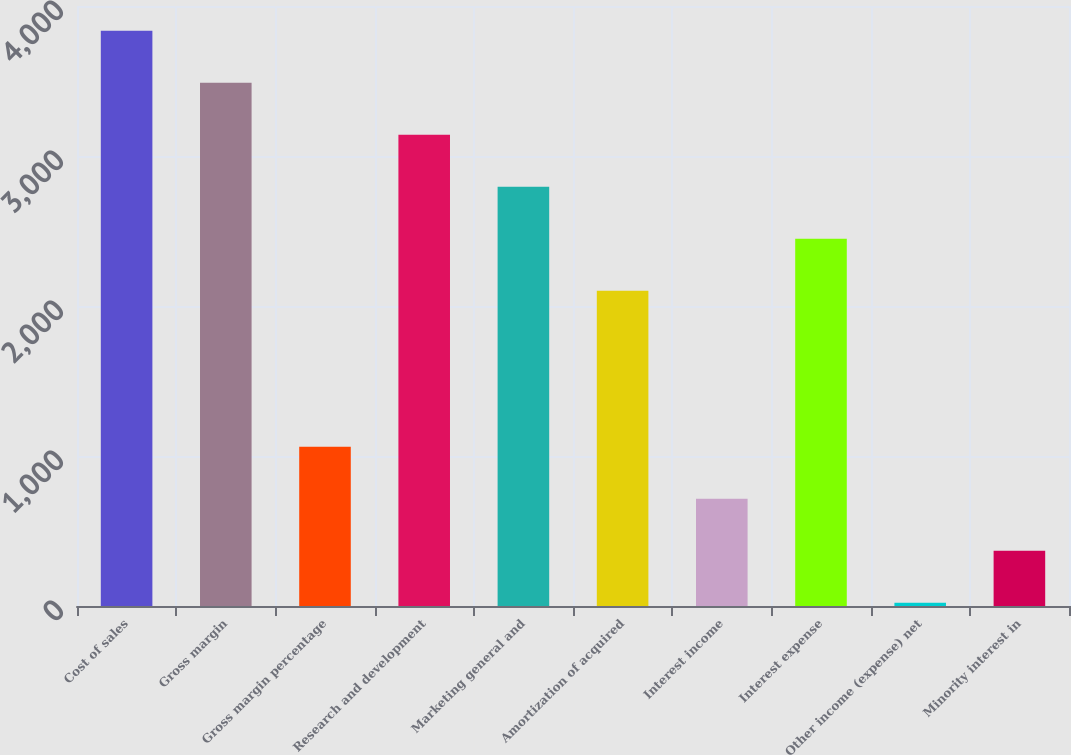<chart> <loc_0><loc_0><loc_500><loc_500><bar_chart><fcel>Cost of sales<fcel>Gross margin<fcel>Gross margin percentage<fcel>Research and development<fcel>Marketing general and<fcel>Amortization of acquired<fcel>Interest income<fcel>Interest expense<fcel>Other income (expense) net<fcel>Minority interest in<nl><fcel>3834.6<fcel>3488<fcel>1061.8<fcel>3141.4<fcel>2794.8<fcel>2101.6<fcel>715.2<fcel>2448.2<fcel>22<fcel>368.6<nl></chart> 